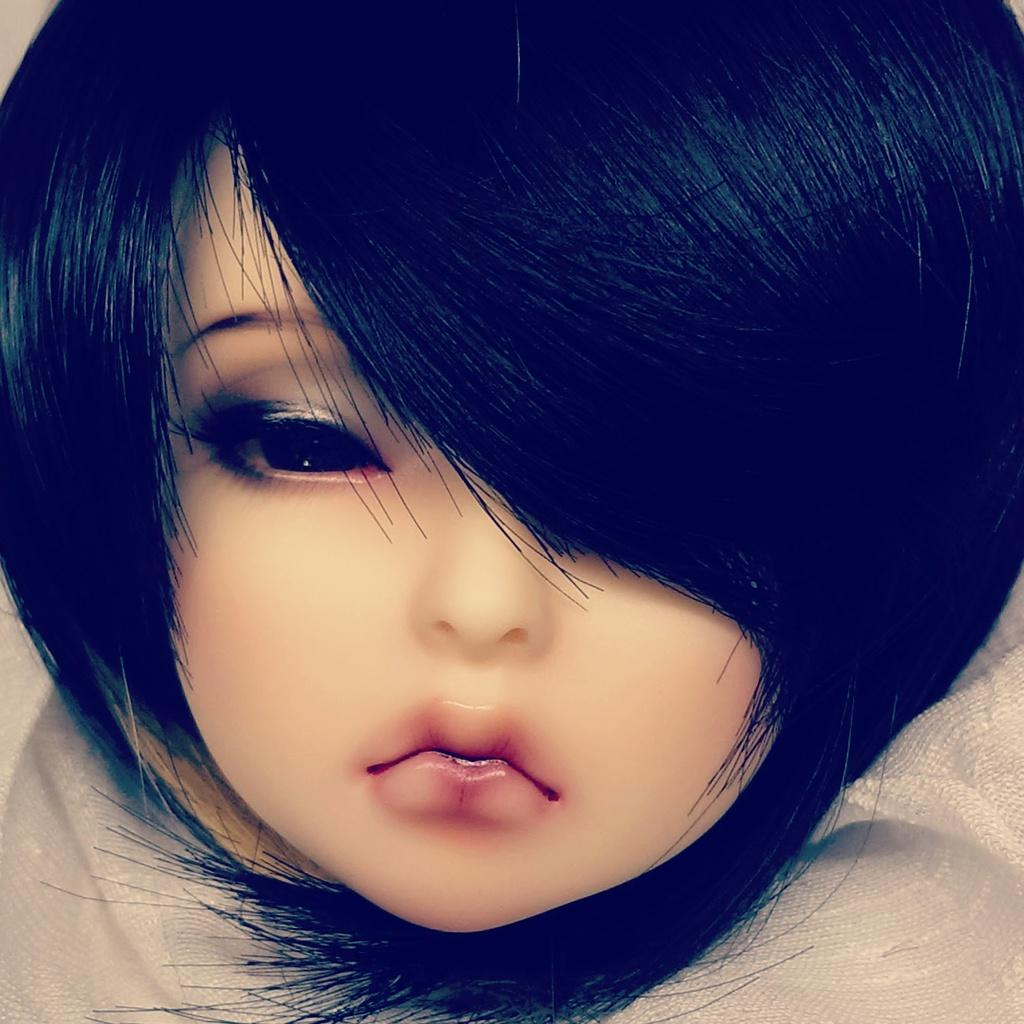What type of picture is shown in the image? The image is an animated picture. Who or what is the main subject of the picture? The subject of the picture is a baby. What type of bear can be seen playing with the baby in the image? There is no bear present in the image; the main subject is a baby. What is the baby's grandfather doing in the image? There is no grandfather present in the image; the main subject is a baby. What color is the kitty that is sitting next to the baby in the image? There is no kitty present in the image; the main subject is a baby. 